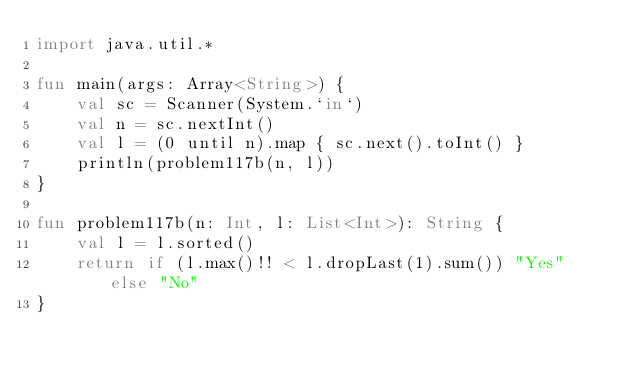<code> <loc_0><loc_0><loc_500><loc_500><_Kotlin_>import java.util.*

fun main(args: Array<String>) {
    val sc = Scanner(System.`in`)
    val n = sc.nextInt()
    val l = (0 until n).map { sc.next().toInt() }
    println(problem117b(n, l))
}

fun problem117b(n: Int, l: List<Int>): String {
    val l = l.sorted()
    return if (l.max()!! < l.dropLast(1).sum()) "Yes" else "No"
}</code> 